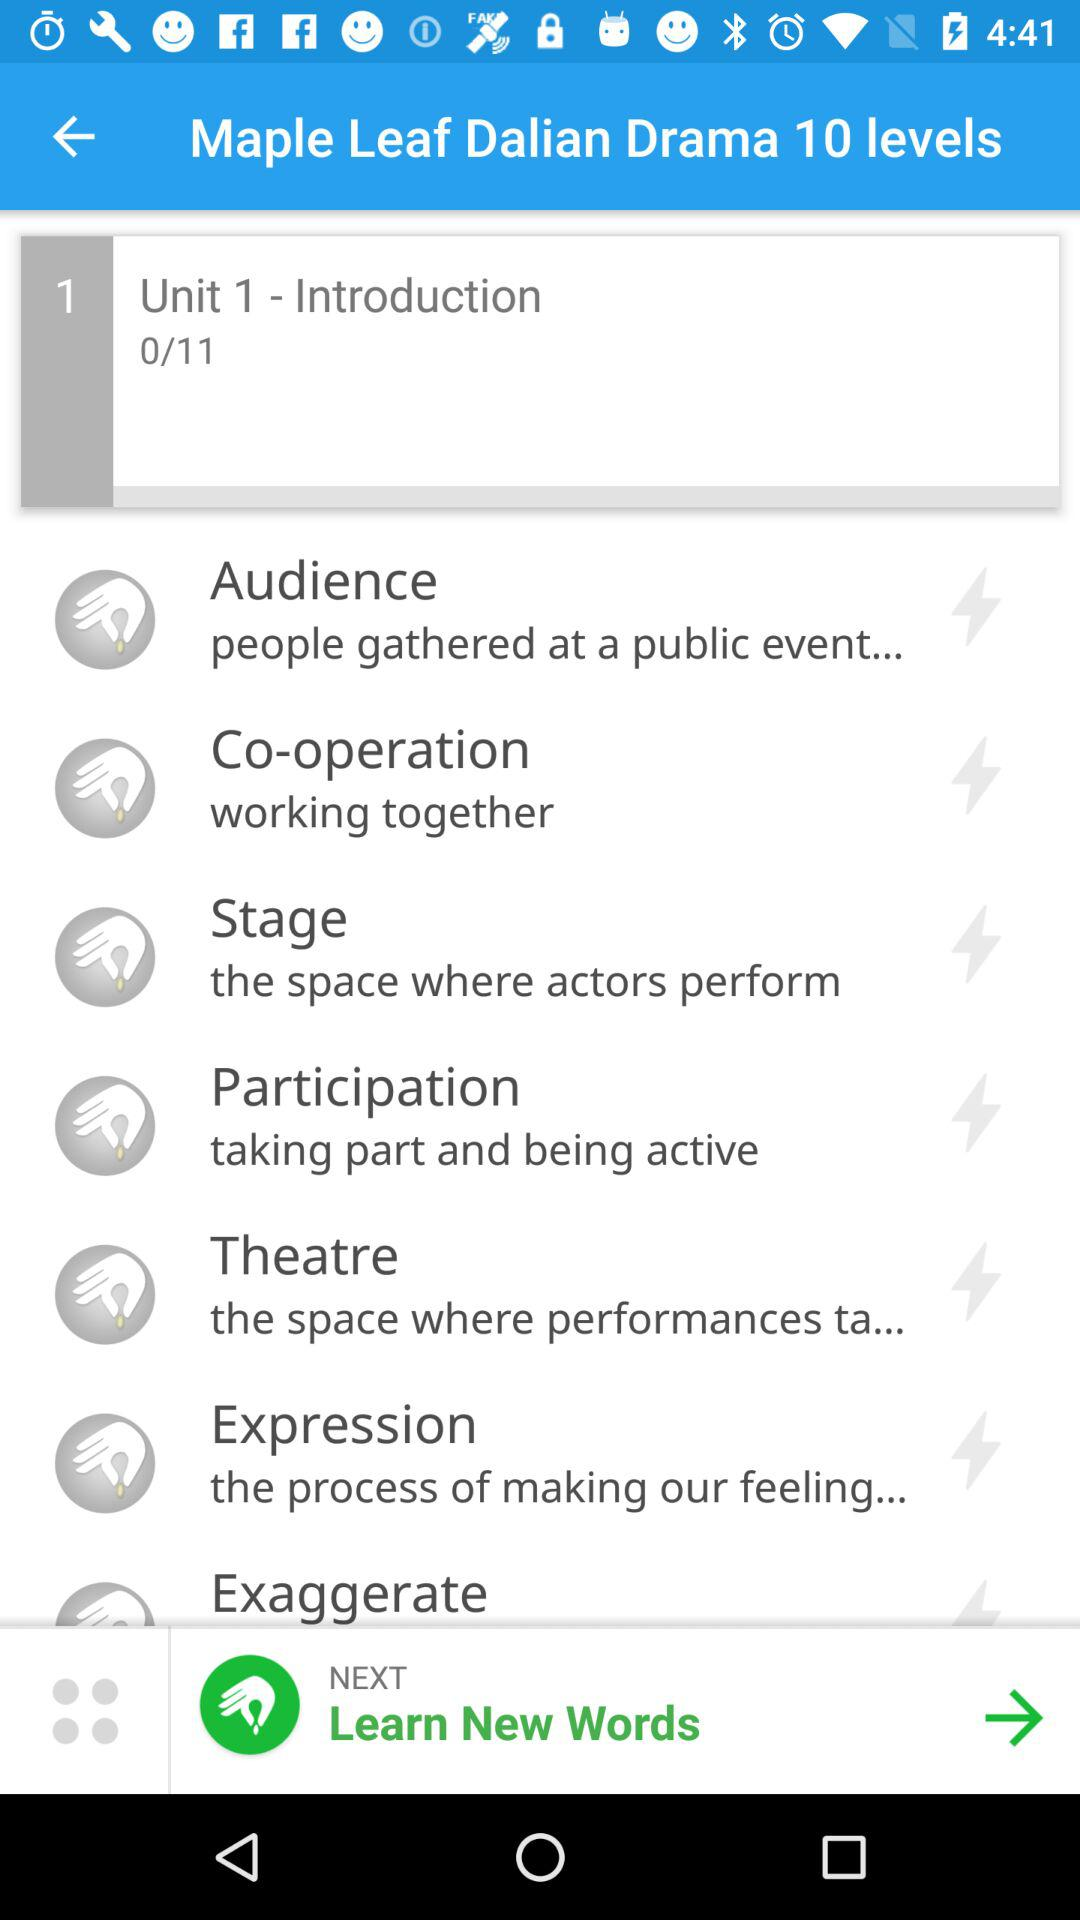What is the name of Unit 1? The name is "Introduction". 